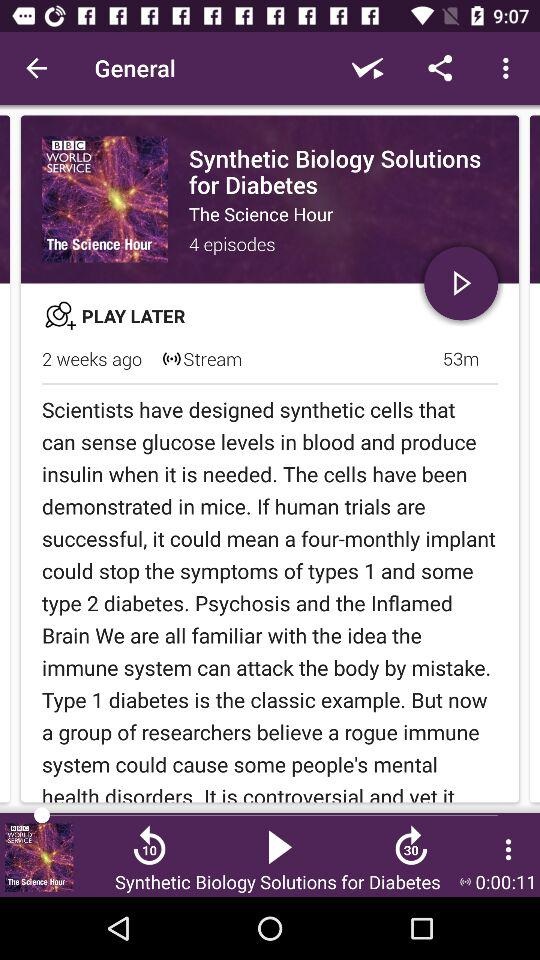How many episodes are there in "The Science Hour"? There are 4 episodes in "The Science Hour". 